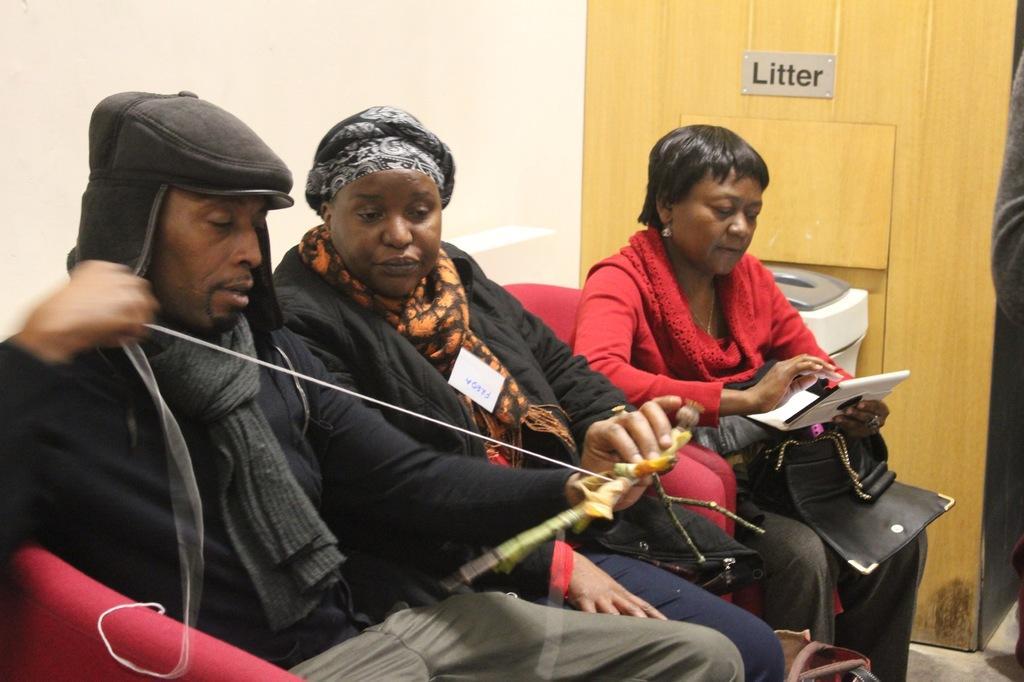Please provide a concise description of this image. In the center of the picture there are people sitting in couch. On the left there is a wall painted white. On the right there is a person. In the center of the background there are dustbin and wooden wall. 